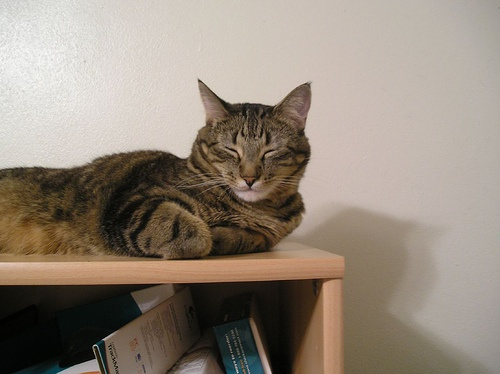Describe the objects in this image and their specific colors. I can see cat in lightgray, black, maroon, and gray tones, book in lightgray, black, and gray tones, and book in lightgray, black, blue, and gray tones in this image. 